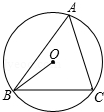Can you explain why angle A is significant in this diagram? Angle A is significant because it represents the angle at which the two secant lines intersect outside the circle. According to the secant angle theorem, this external angle is equal to half the difference of the measures of the arcs intercepted by the angle, which is a fundamental concept in circle geometry. 